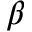Convert formula to latex. <formula><loc_0><loc_0><loc_500><loc_500>\beta</formula> 